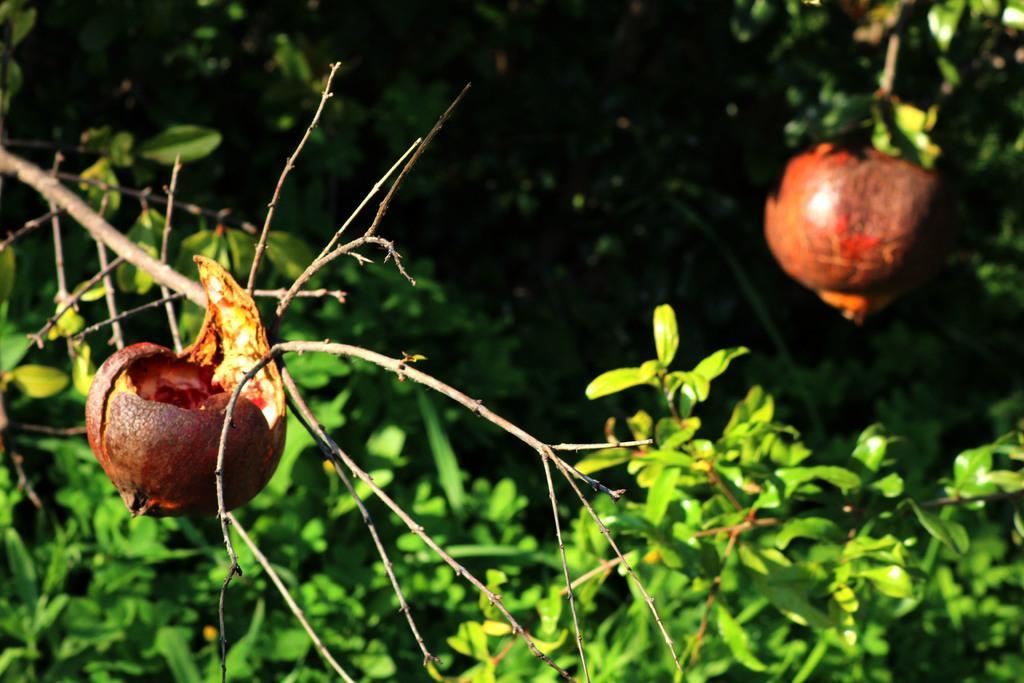In one or two sentences, can you explain what this image depicts? In this image I can see a tree which is green in color and to it I can see two fruits which are orange and brown in color. I can see the black colored background. 